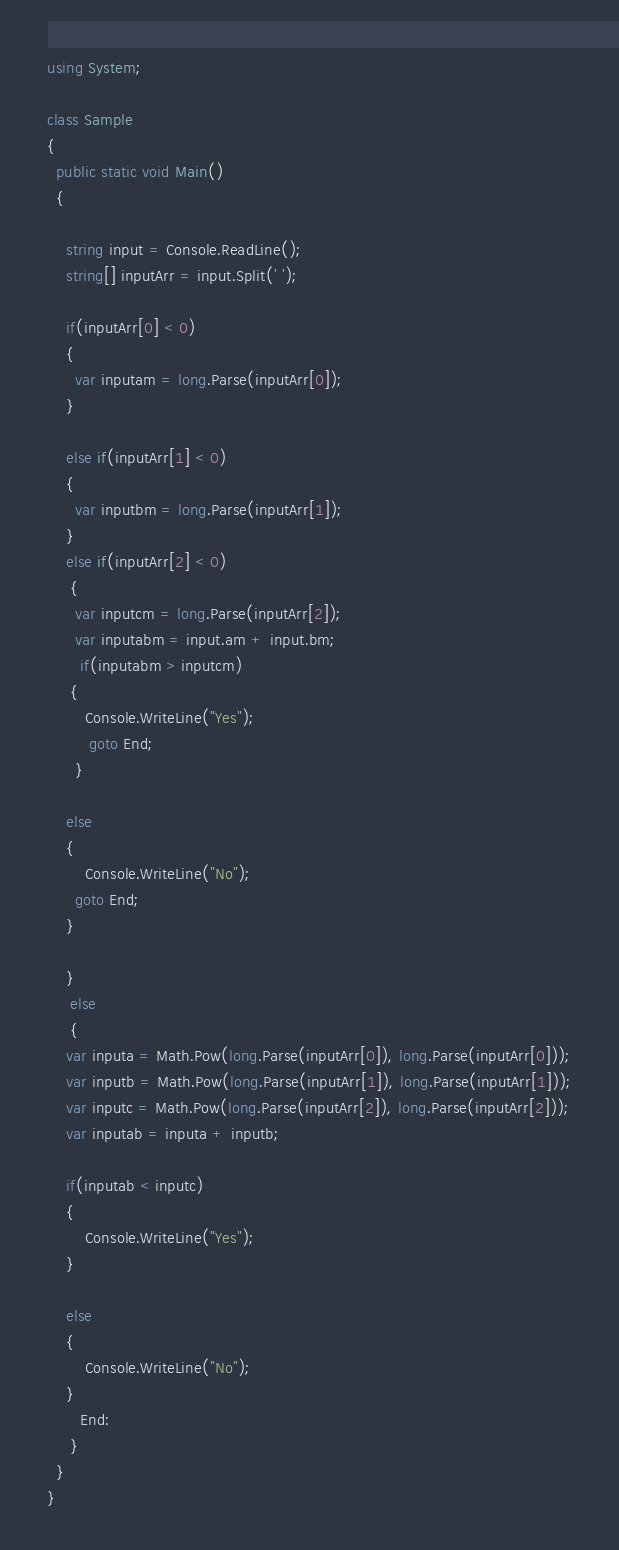<code> <loc_0><loc_0><loc_500><loc_500><_C#_>using System;

class Sample
{
  public static void Main()
  {
  	
    string input = Console.ReadLine();
    string[] inputArr = input.Split(' ');

    if(inputArr[0] < 0)
    {
      var inputam = long.Parse(inputArr[0]);
    }
    
    else if(inputArr[1] < 0)
    {
      var inputbm = long.Parse(inputArr[1]);
    }
    else if(inputArr[2] < 0)
   	 { 
      var inputcm = long.Parse(inputArr[2]);
      var inputabm = input.am + input.bm;
   	   if(inputabm > inputcm)
   	 {
   	 	Console.WriteLine("Yes");
         goto End;
  	  }
   	 
    else
    {
    	Console.WriteLine("No");
      goto End;
    }
      
    }
     else
     {     
    var inputa = Math.Pow(long.Parse(inputArr[0]), long.Parse(inputArr[0]));
    var inputb = Math.Pow(long.Parse(inputArr[1]), long.Parse(inputArr[1]));
    var inputc = Math.Pow(long.Parse(inputArr[2]), long.Parse(inputArr[2]));
    var inputab = inputa + inputb;
       
    if(inputab < inputc)
    {
    	Console.WriteLine("Yes");
    }
    
    else
    {
    	Console.WriteLine("No");
    }
       End:
     }
  }
}
</code> 